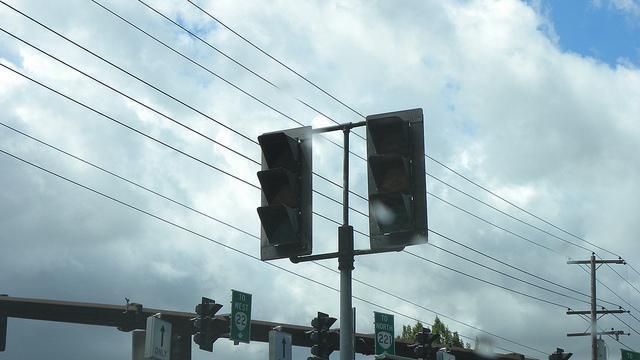How many signs are in the picture?
Give a very brief answer. 4. How many traffic lights are there?
Give a very brief answer. 2. 